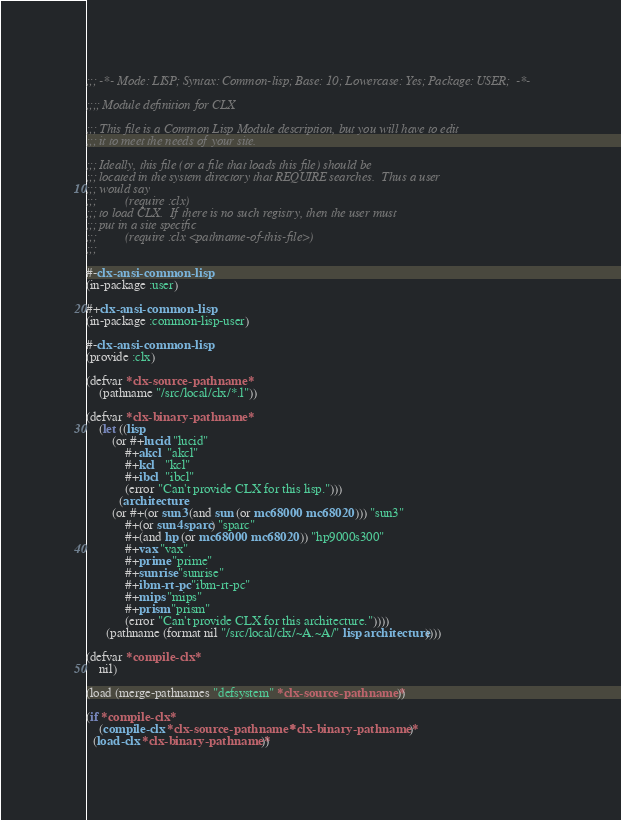Convert code to text. <code><loc_0><loc_0><loc_500><loc_500><_Lisp_>;;; -*- Mode: LISP; Syntax: Common-lisp; Base: 10; Lowercase: Yes; Package: USER;  -*-

;;;; Module definition for CLX

;;; This file is a Common Lisp Module description, but you will have to edit
;;; it to meet the needs of your site.

;;; Ideally, this file (or a file that loads this file) should be
;;; located in the system directory that REQUIRE searches.  Thus a user
;;; would say
;;;			(require :clx)
;;; to load CLX.  If there is no such registry, then the user must
;;; put in a site specific
;;;			(require :clx <pathname-of-this-file>)
;;;

#-clx-ansi-common-lisp 
(in-package :user)

#+clx-ansi-common-lisp
(in-package :common-lisp-user)

#-clx-ansi-common-lisp
(provide :clx)

(defvar *clx-source-pathname*
	(pathname "/src/local/clx/*.l"))

(defvar *clx-binary-pathname*
	(let ((lisp
		(or #+lucid "lucid"
		    #+akcl  "akcl"
		    #+kcl   "kcl"
		    #+ibcl  "ibcl"
		    (error "Can't provide CLX for this lisp.")))
	      (architecture
		(or #+(or sun3 (and sun (or mc68000 mc68020))) "sun3"
		    #+(or sun4 sparc) "sparc"
		    #+(and hp (or mc68000 mc68020)) "hp9000s300"
		    #+vax "vax"
		    #+prime "prime"
		    #+sunrise "sunrise"
		    #+ibm-rt-pc "ibm-rt-pc"
		    #+mips "mips"
		    #+prism "prism"
		    (error "Can't provide CLX for this architecture."))))
	  (pathname (format nil "/src/local/clx/~A.~A/" lisp architecture))))

(defvar *compile-clx*
	nil)

(load (merge-pathnames "defsystem" *clx-source-pathname*))

(if *compile-clx*
    (compile-clx *clx-source-pathname* *clx-binary-pathname*)
  (load-clx *clx-binary-pathname*))
</code> 